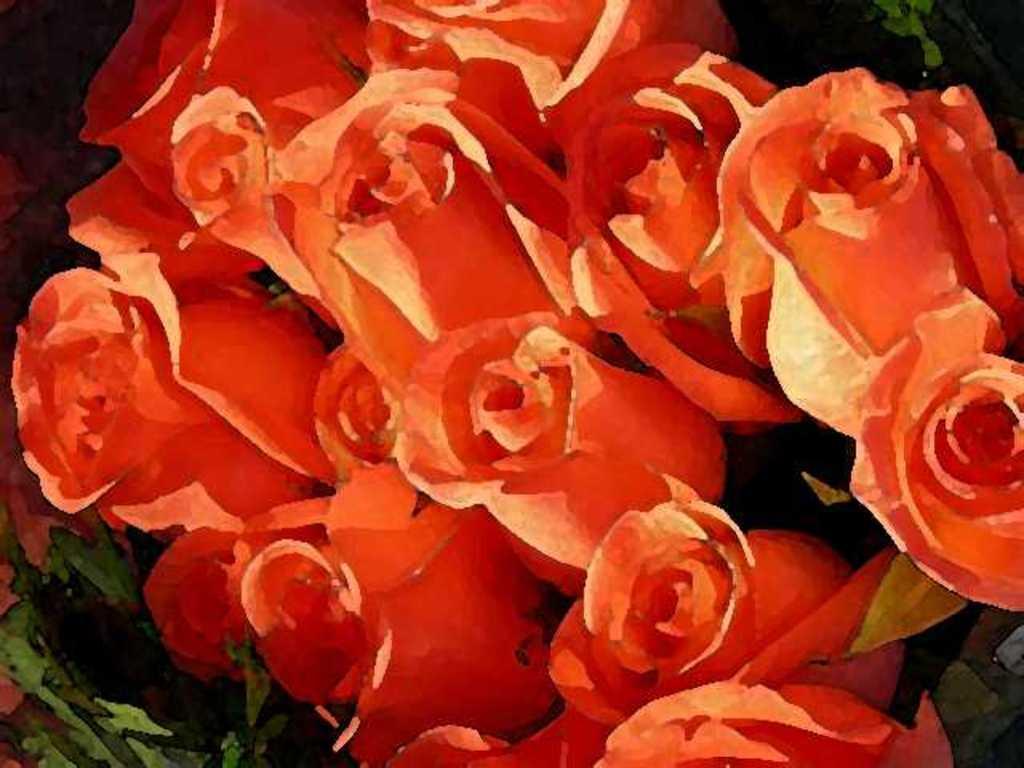Could you give a brief overview of what you see in this image? In this image we can see a bunch of roses are painted. 